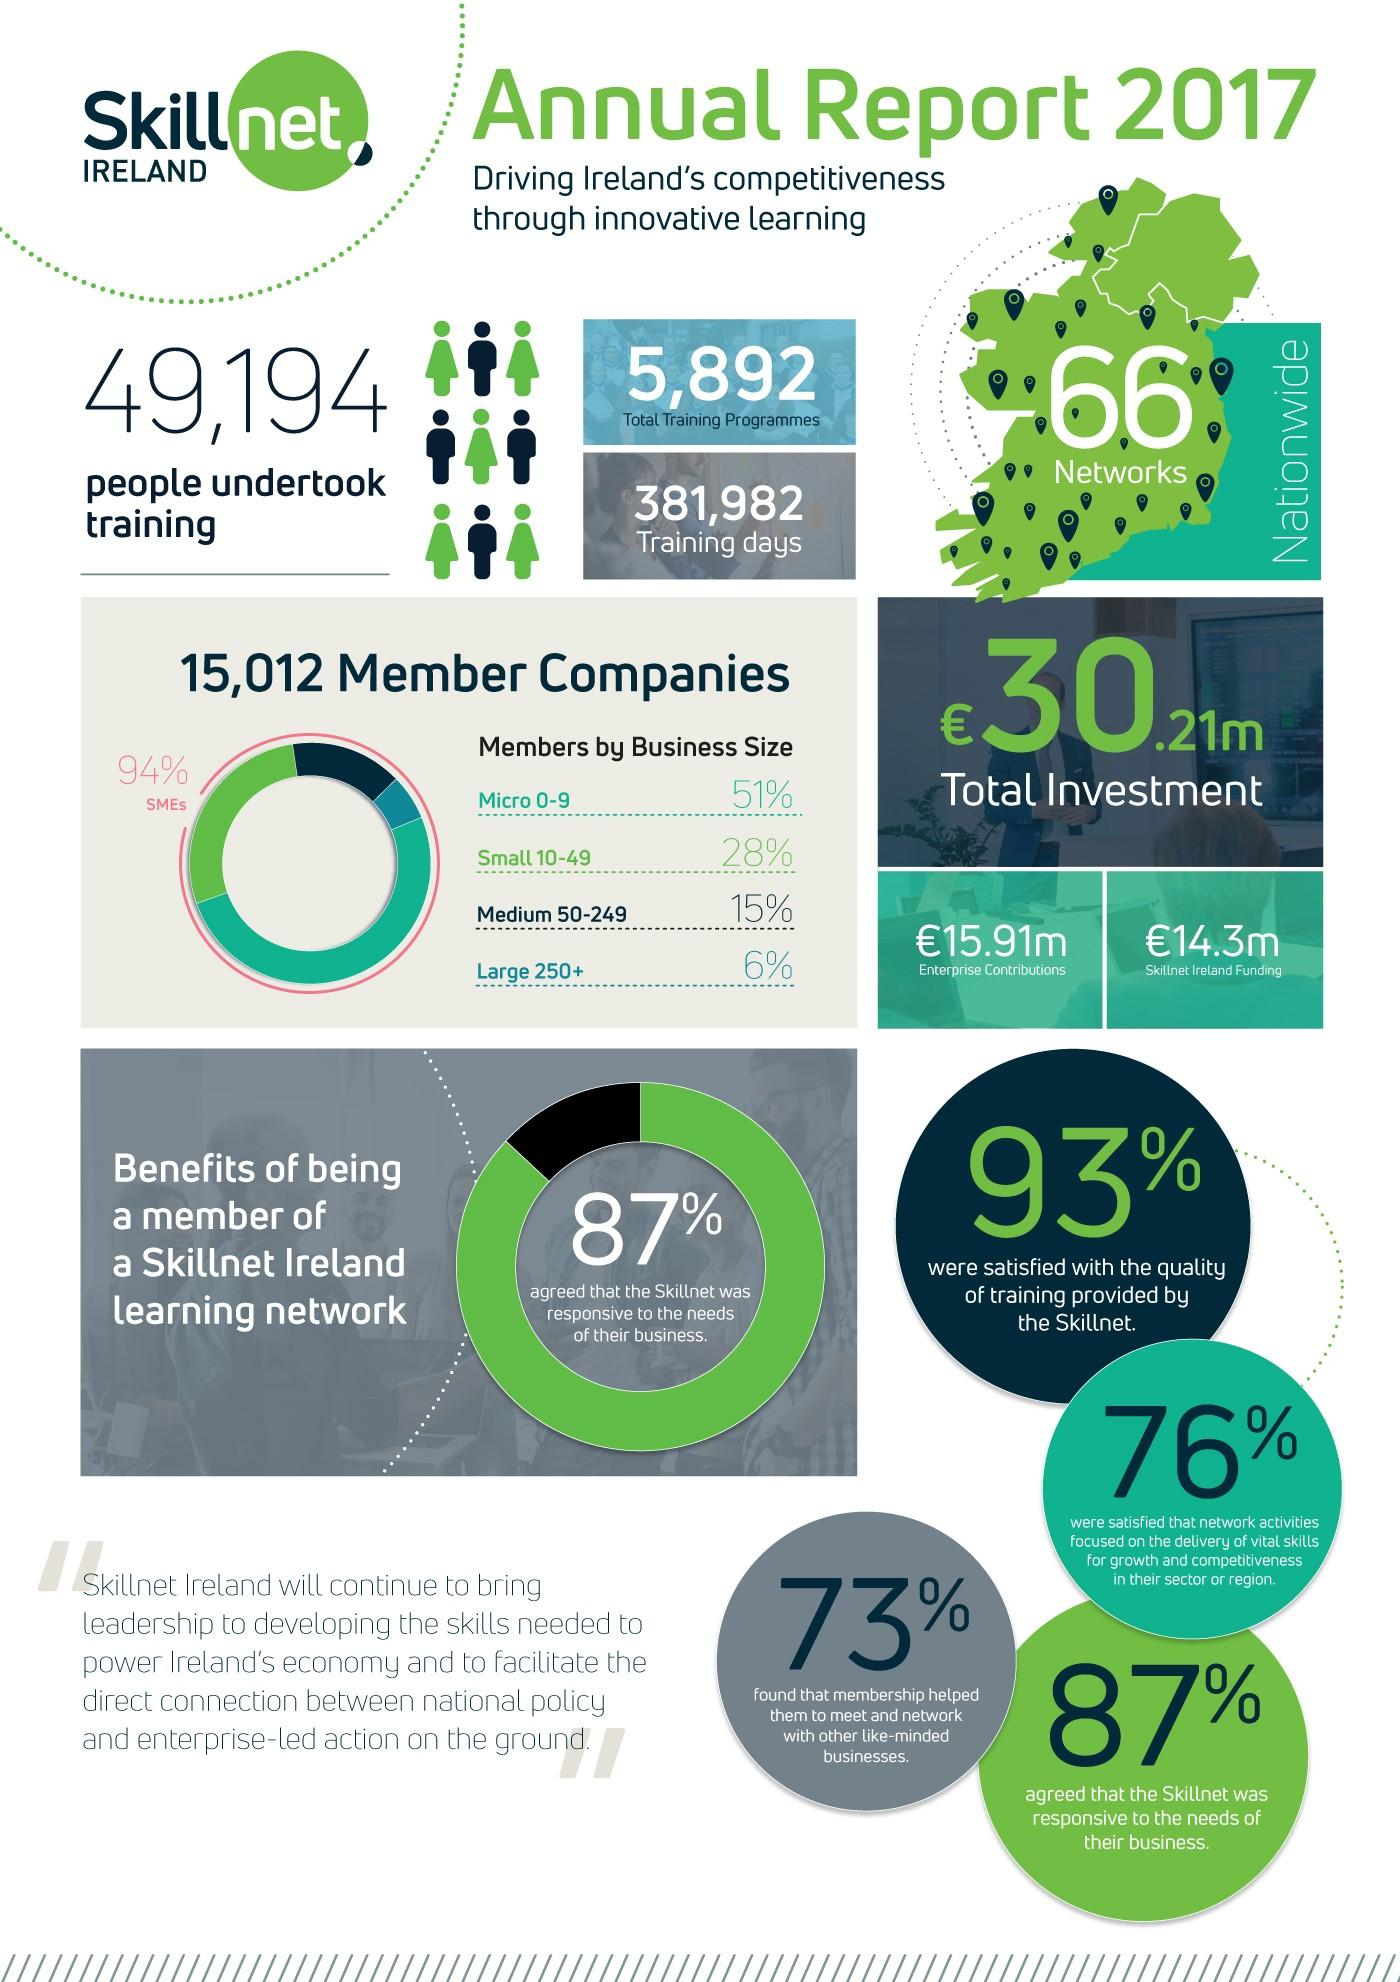Give some essential details in this illustration. According to the survey, 13% of the respondents believed that Skillnet was not responsive to the needs of their business. According to the survey, 24% of the respondents were not satisfied with the network activities focused on delivering vital skills. The combined percentage of micro and small enterprises is 79%. When medium and small units are taken together, the resulting percentage is 43%. The results of the survey showed that 7% of the respondents were not satisfied with the quality of training provided by the Skillnet. 